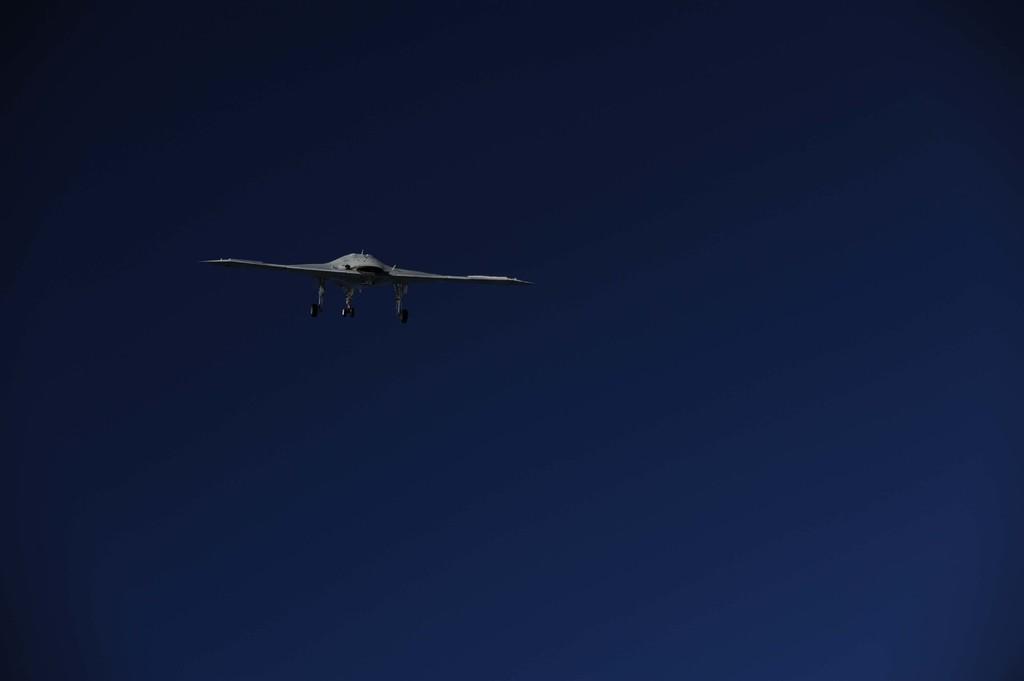Describe this image in one or two sentences. In this picture we can see an aircraft in the sky. 